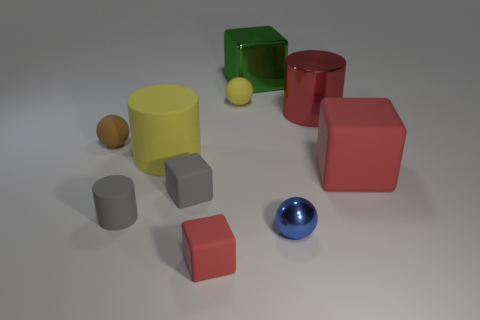Subtract all matte cylinders. How many cylinders are left? 1 Subtract all purple cylinders. How many red cubes are left? 2 Subtract all green blocks. Subtract all gray metallic cylinders. How many objects are left? 9 Add 7 blue spheres. How many blue spheres are left? 8 Add 3 big blue shiny cylinders. How many big blue shiny cylinders exist? 3 Subtract all brown spheres. How many spheres are left? 2 Subtract 0 blue cylinders. How many objects are left? 10 Subtract all cubes. How many objects are left? 6 Subtract 4 blocks. How many blocks are left? 0 Subtract all green balls. Subtract all gray cylinders. How many balls are left? 3 